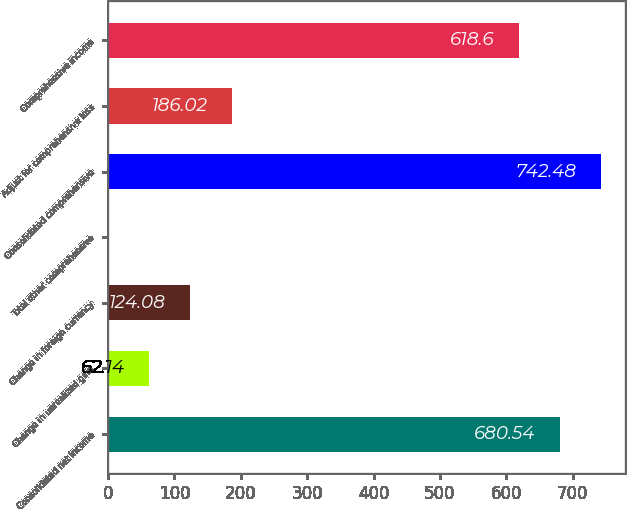Convert chart to OTSL. <chart><loc_0><loc_0><loc_500><loc_500><bar_chart><fcel>Consolidated net income<fcel>Change in unrealized gain<fcel>Change in foreign currency<fcel>Total other comprehensive<fcel>Consolidated comprehensive<fcel>Adjust for comprehensive loss<fcel>Comprehensive income<nl><fcel>680.54<fcel>62.14<fcel>124.08<fcel>0.2<fcel>742.48<fcel>186.02<fcel>618.6<nl></chart> 